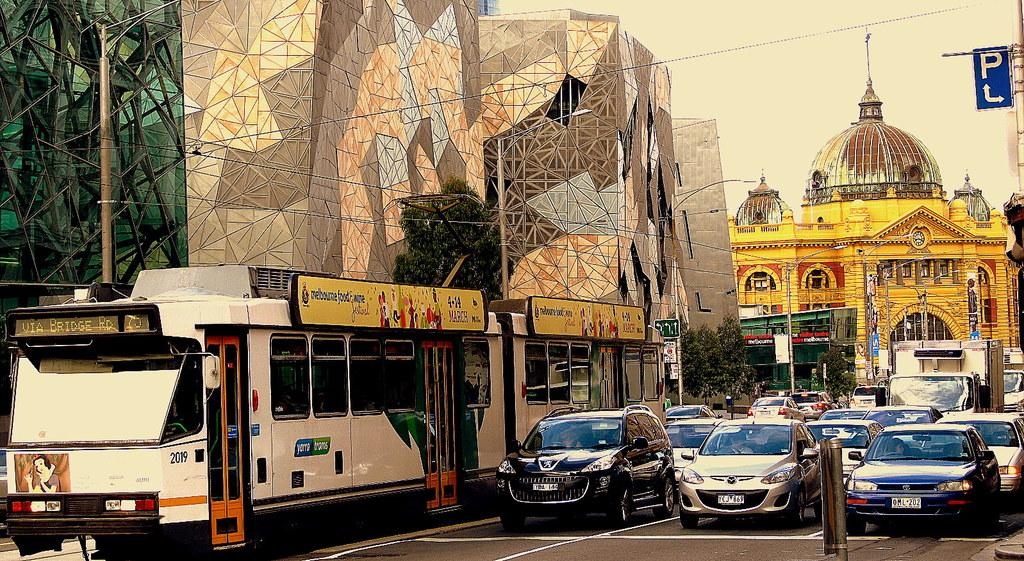<image>
Give a short and clear explanation of the subsequent image. A street full of cars with a sign on the side of the street with the letter P. 